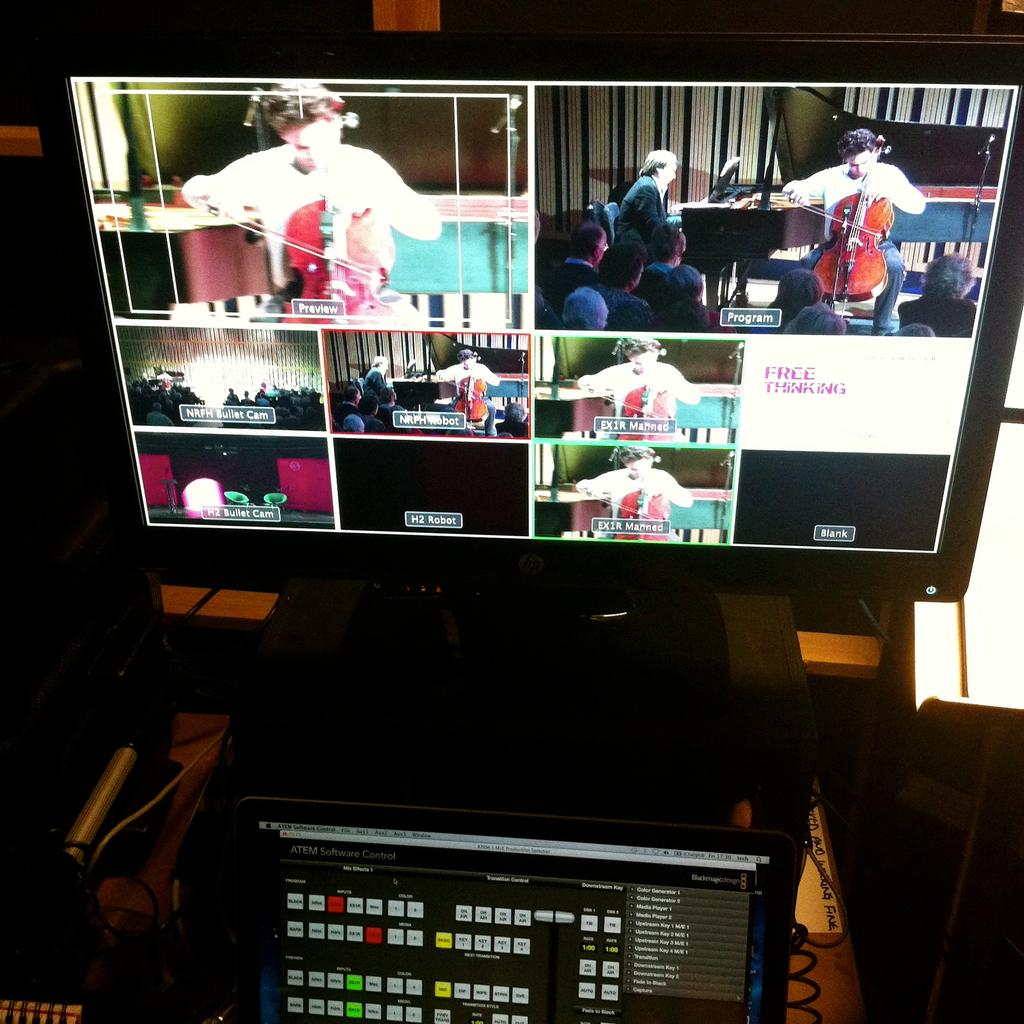<image>
Describe the image concisely. A screen has several different scene's on it all labeled with things such as preview, program, and H2 Bullet cam. 